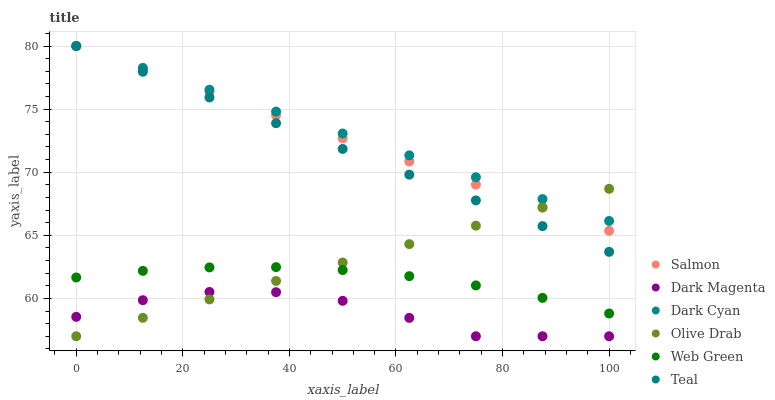Does Dark Magenta have the minimum area under the curve?
Answer yes or no. Yes. Does Dark Cyan have the maximum area under the curve?
Answer yes or no. Yes. Does Salmon have the minimum area under the curve?
Answer yes or no. No. Does Salmon have the maximum area under the curve?
Answer yes or no. No. Is Olive Drab the smoothest?
Answer yes or no. Yes. Is Dark Magenta the roughest?
Answer yes or no. Yes. Is Salmon the smoothest?
Answer yes or no. No. Is Salmon the roughest?
Answer yes or no. No. Does Dark Magenta have the lowest value?
Answer yes or no. Yes. Does Salmon have the lowest value?
Answer yes or no. No. Does Dark Cyan have the highest value?
Answer yes or no. Yes. Does Web Green have the highest value?
Answer yes or no. No. Is Dark Magenta less than Teal?
Answer yes or no. Yes. Is Salmon greater than Web Green?
Answer yes or no. Yes. Does Olive Drab intersect Web Green?
Answer yes or no. Yes. Is Olive Drab less than Web Green?
Answer yes or no. No. Is Olive Drab greater than Web Green?
Answer yes or no. No. Does Dark Magenta intersect Teal?
Answer yes or no. No. 